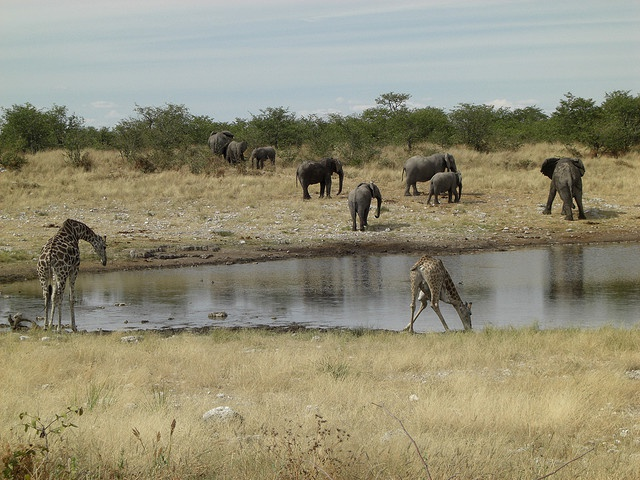Describe the objects in this image and their specific colors. I can see giraffe in lightgray, black, and gray tones, giraffe in lightgray, gray, black, and darkgray tones, elephant in lightgray, black, and gray tones, elephant in lightgray, black, tan, and gray tones, and elephant in lightgray, black, gray, and tan tones in this image. 